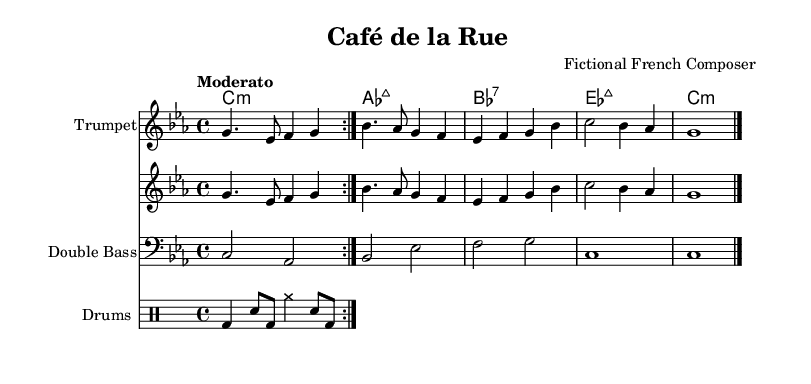What is the key signature of this music? The key signature indicates C minor, as seen by the presence of three flat notes (B♭, E♭, and A♭) at the beginning of the score.
Answer: C minor What is the time signature of this music? The time signature is 4/4, which is shown at the beginning, indicating four beats per measure and a quarter note gets one beat.
Answer: 4/4 What is the tempo marking of this piece? The tempo marking states "Moderato," which suggests a moderate speed, commonly interpreted as walking pace.
Answer: Moderato How many measures are in the piano part? By counting the segments between the bar lines in the piano part, there are a total of five measures present.
Answer: 5 What is the first chord in the chord names section? The first chord in the chord names section is indicated as C minor, which is written as c1:m at the start of the chord sequence.
Answer: C minor How does the trumpet part relate to the piano part in terms of melody? The trumpet part has a similar melodic line to the piano part, often mirroring its phrases, which creates an interplay between the two instruments.
Answer: Similar melody Which instrument plays the bass line? The bass line is performed by the double bass, as labeled at the beginning of the bass staff section within the score.
Answer: Double bass 